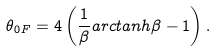<formula> <loc_0><loc_0><loc_500><loc_500>\theta _ { 0 F } = 4 \left ( \frac { 1 } { \beta } a r c t a n h \beta - 1 \right ) .</formula> 